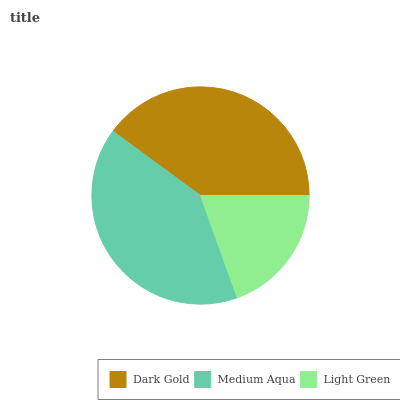Is Light Green the minimum?
Answer yes or no. Yes. Is Medium Aqua the maximum?
Answer yes or no. Yes. Is Medium Aqua the minimum?
Answer yes or no. No. Is Light Green the maximum?
Answer yes or no. No. Is Medium Aqua greater than Light Green?
Answer yes or no. Yes. Is Light Green less than Medium Aqua?
Answer yes or no. Yes. Is Light Green greater than Medium Aqua?
Answer yes or no. No. Is Medium Aqua less than Light Green?
Answer yes or no. No. Is Dark Gold the high median?
Answer yes or no. Yes. Is Dark Gold the low median?
Answer yes or no. Yes. Is Medium Aqua the high median?
Answer yes or no. No. Is Light Green the low median?
Answer yes or no. No. 